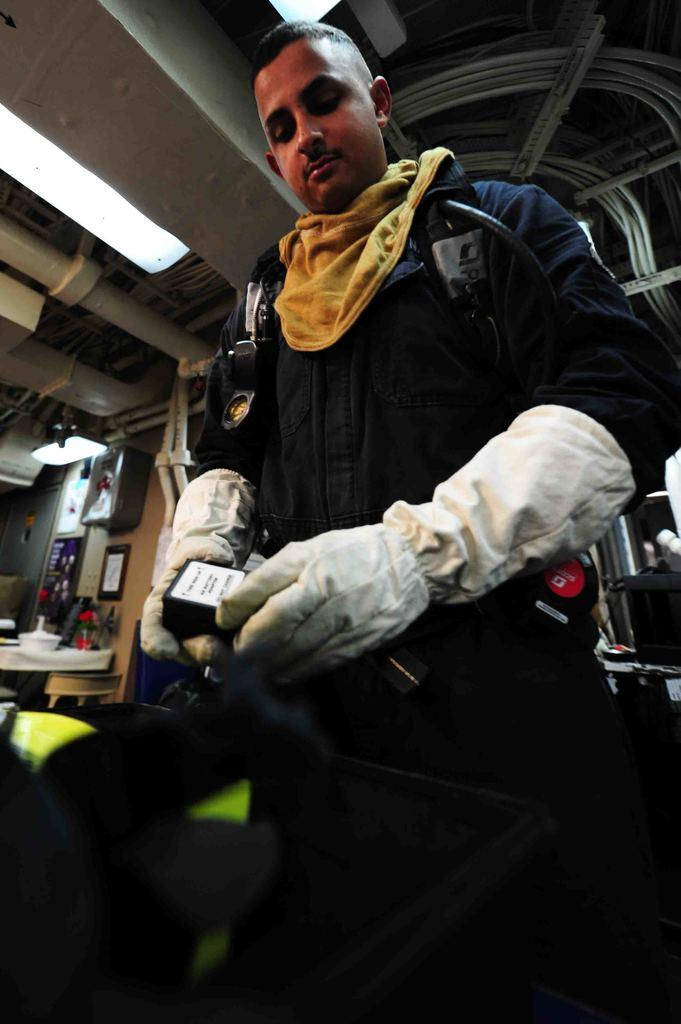Who is the main subject in the image? There is a man standing in the center of the image. What can be seen in the background of the image? There is a table and a wall in the background of the image. What is visible at the top of the image? There are lights visible at the top of the image. What type of magic is the man performing in the image? There is no indication of magic or any magical activity in the image. 